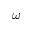Convert formula to latex. <formula><loc_0><loc_0><loc_500><loc_500>\omega</formula> 